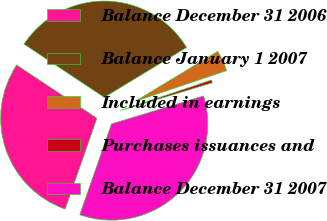Convert chart. <chart><loc_0><loc_0><loc_500><loc_500><pie_chart><fcel>Balance December 31 2006<fcel>Balance January 1 2007<fcel>Included in earnings<fcel>Purchases issuances and<fcel>Balance December 31 2007<nl><fcel>28.97%<fcel>32.01%<fcel>3.51%<fcel>0.47%<fcel>35.04%<nl></chart> 